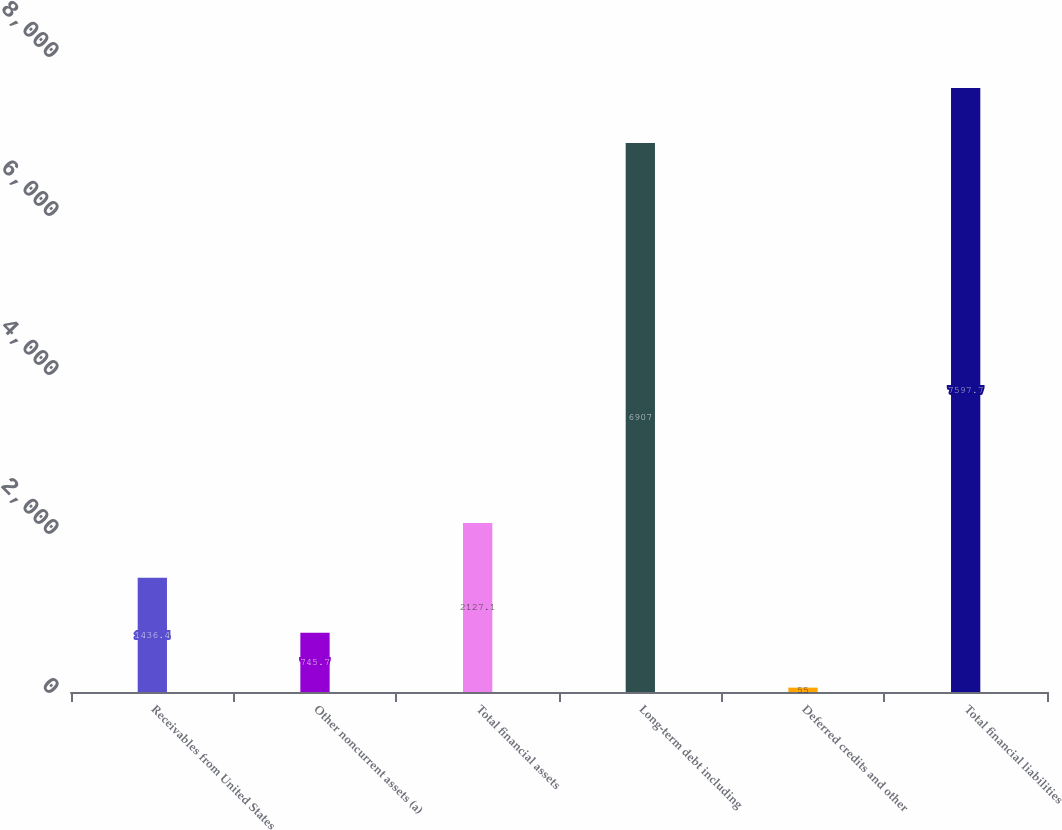Convert chart. <chart><loc_0><loc_0><loc_500><loc_500><bar_chart><fcel>Receivables from United States<fcel>Other noncurrent assets (a)<fcel>Total financial assets<fcel>Long-term debt including<fcel>Deferred credits and other<fcel>Total financial liabilities<nl><fcel>1436.4<fcel>745.7<fcel>2127.1<fcel>6907<fcel>55<fcel>7597.7<nl></chart> 